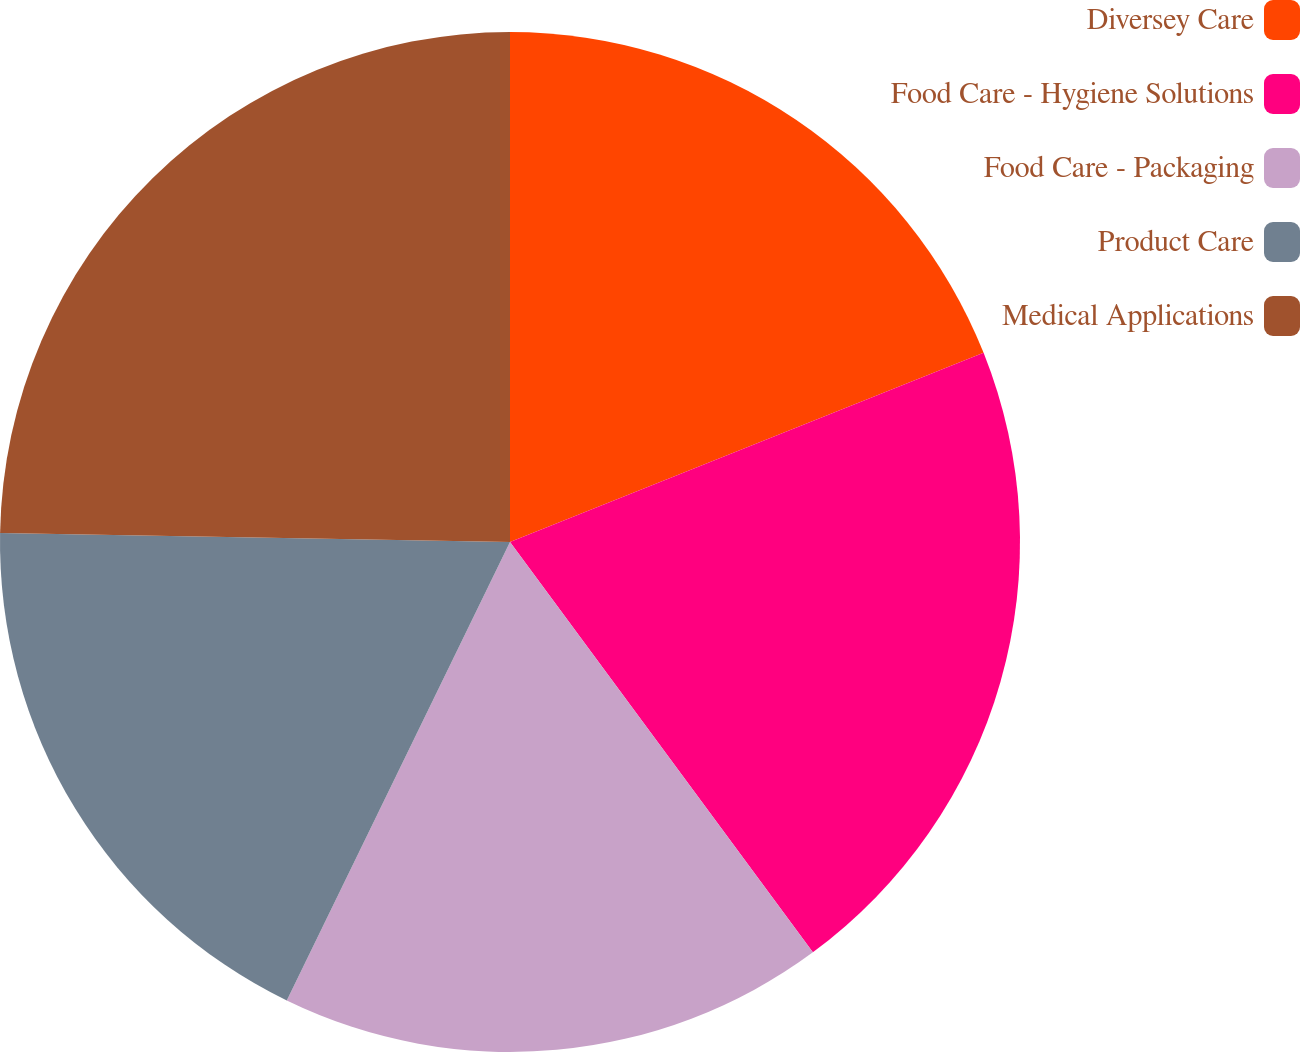Convert chart to OTSL. <chart><loc_0><loc_0><loc_500><loc_500><pie_chart><fcel>Diversey Care<fcel>Food Care - Hygiene Solutions<fcel>Food Care - Packaging<fcel>Product Care<fcel>Medical Applications<nl><fcel>18.95%<fcel>20.93%<fcel>17.33%<fcel>18.07%<fcel>24.72%<nl></chart> 